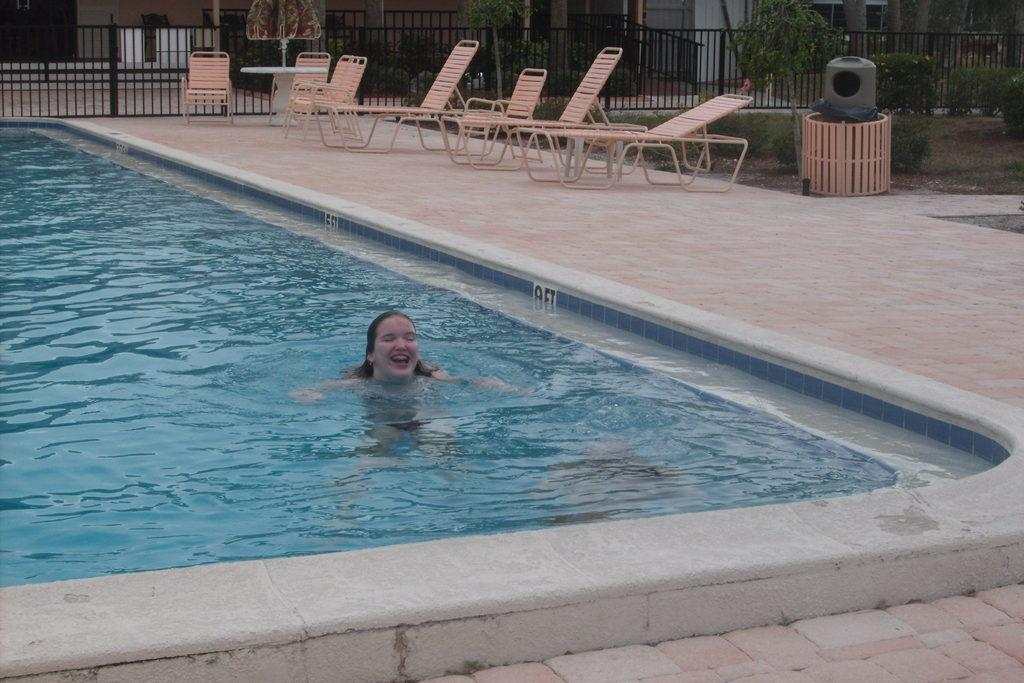What is the main subject of the image? There is a lady in a pool in the center of the image. What can be seen in the background of the image? In the background, there are chairs, grilles, a table, an umbrella, plants, grass, a floor, and a wall. Can you describe the setting of the image? The image appears to be set outdoors, with a pool, chairs, and a table, as well as plants and grass. What type of juice is being served at the table in the image? There is no juice or table serving juice present in the image. Can you hear any music playing in the background of the image? The image is a still photograph, so there is no sound or music present. 